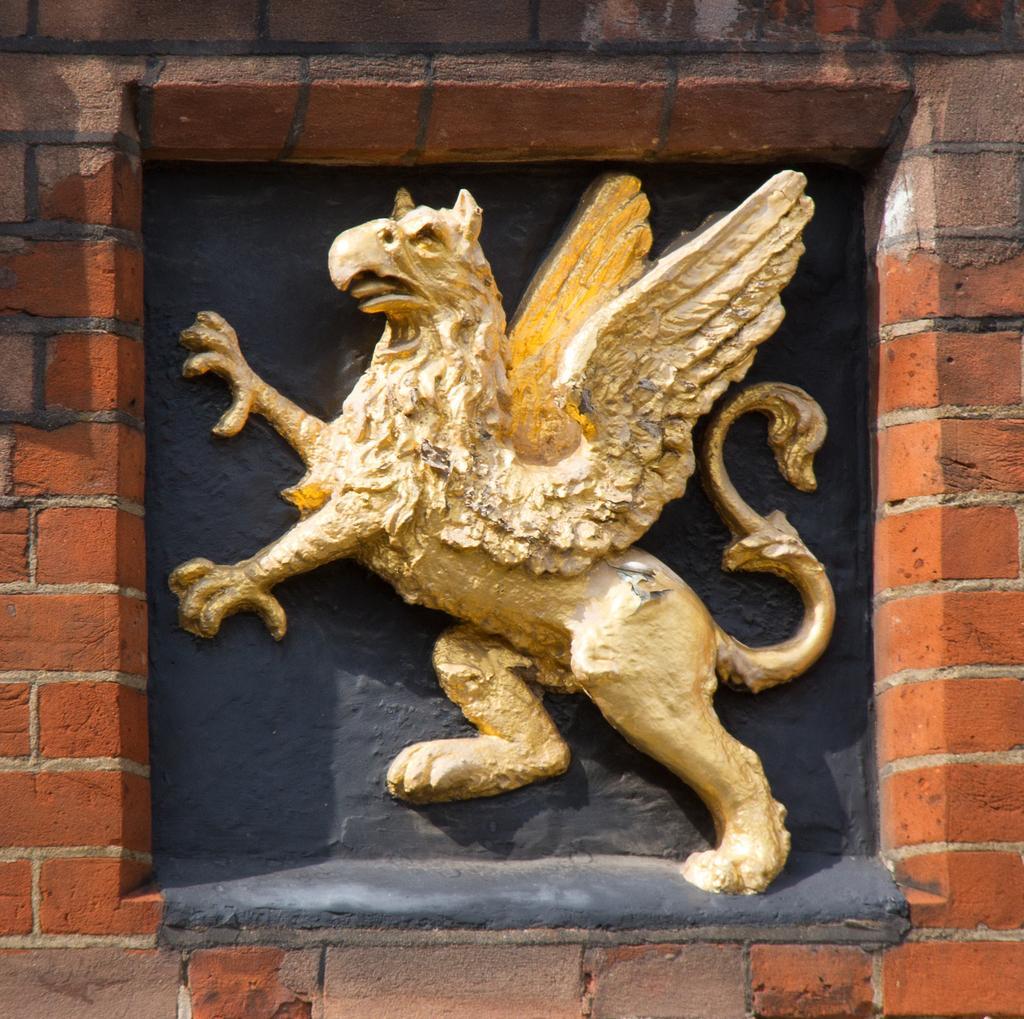Can you describe this image briefly? In this picture we can see a sculpture on the wall. 